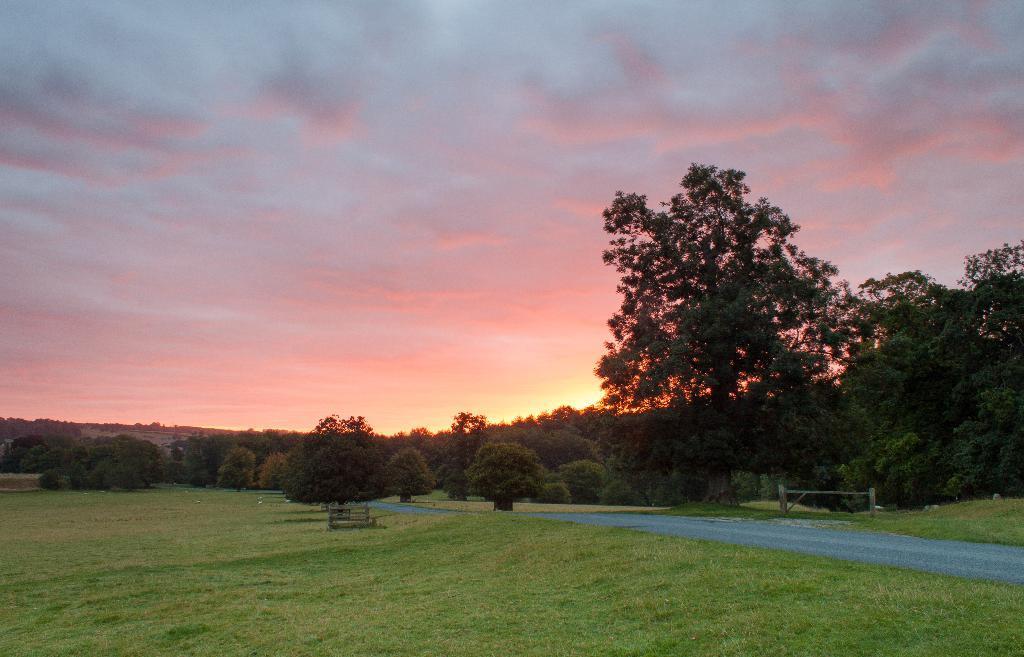Describe this image in one or two sentences. In this picture there are trees in the center. At the bottom, there is grass. Towards the right, there is a road. On the top, there is a sky with clouds. 